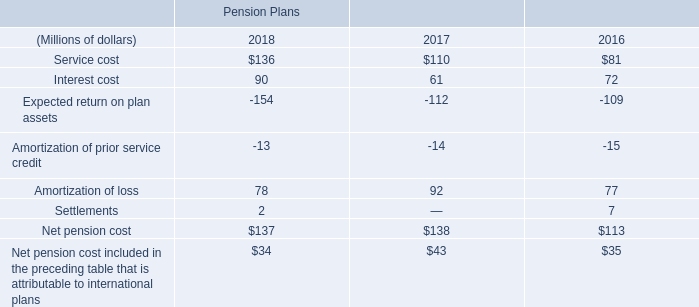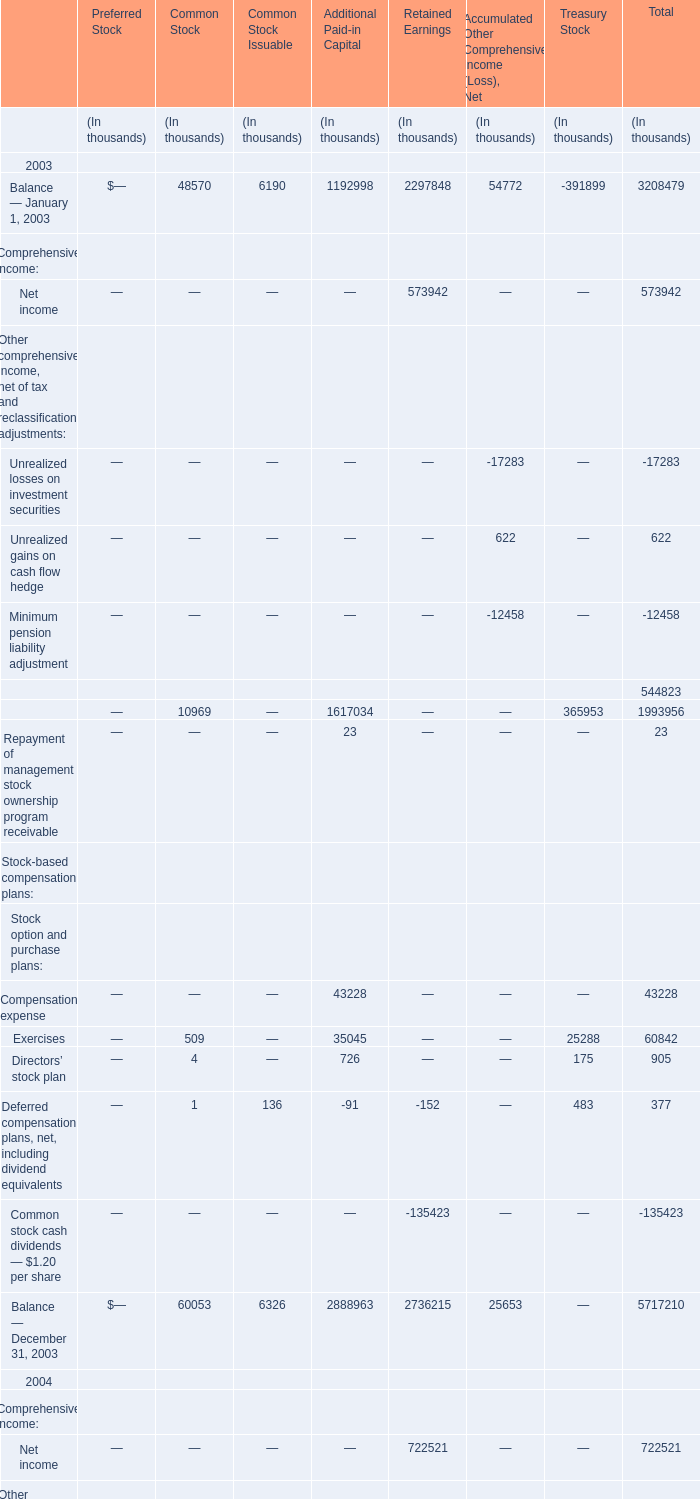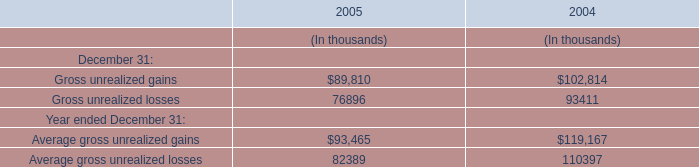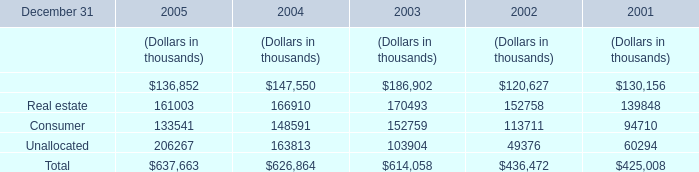Which year is Net income for Retained Earnings the least? 
Answer: 2003. 